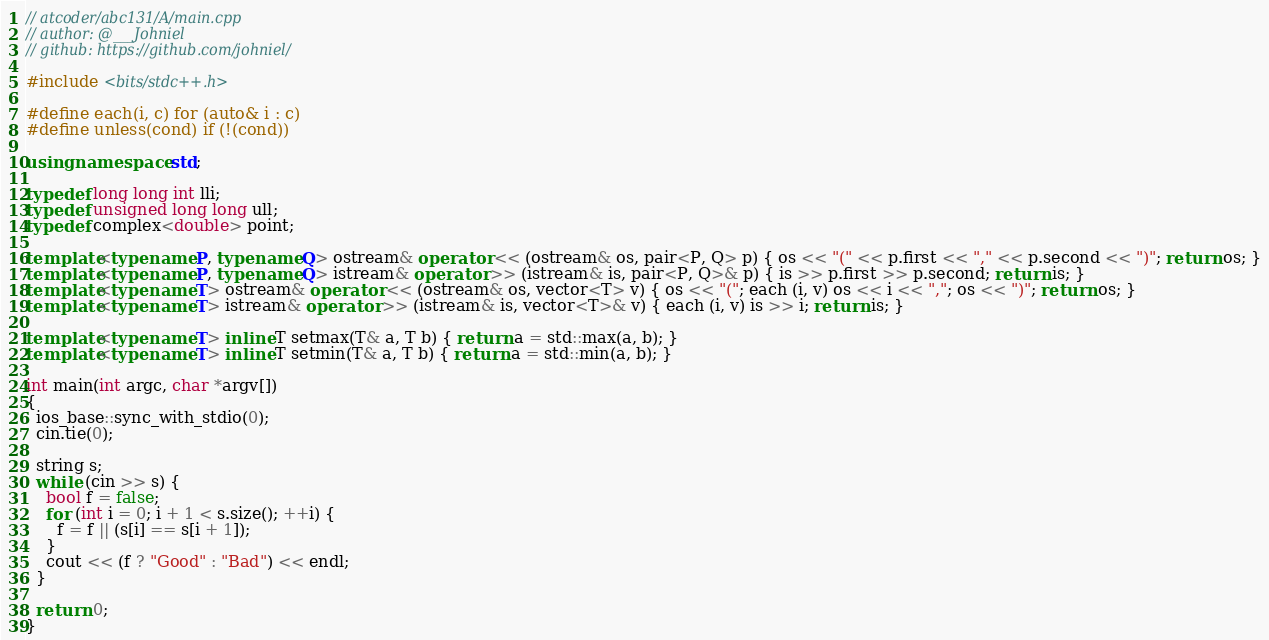<code> <loc_0><loc_0><loc_500><loc_500><_C++_>// atcoder/abc131/A/main.cpp
// author: @___Johniel
// github: https://github.com/johniel/

#include <bits/stdc++.h>

#define each(i, c) for (auto& i : c)
#define unless(cond) if (!(cond))

using namespace std;

typedef long long int lli;
typedef unsigned long long ull;
typedef complex<double> point;

template<typename P, typename Q> ostream& operator << (ostream& os, pair<P, Q> p) { os << "(" << p.first << "," << p.second << ")"; return os; }
template<typename P, typename Q> istream& operator >> (istream& is, pair<P, Q>& p) { is >> p.first >> p.second; return is; }
template<typename T> ostream& operator << (ostream& os, vector<T> v) { os << "("; each (i, v) os << i << ","; os << ")"; return os; }
template<typename T> istream& operator >> (istream& is, vector<T>& v) { each (i, v) is >> i; return is; }

template<typename T> inline T setmax(T& a, T b) { return a = std::max(a, b); }
template<typename T> inline T setmin(T& a, T b) { return a = std::min(a, b); }

int main(int argc, char *argv[])
{
  ios_base::sync_with_stdio(0);
  cin.tie(0);

  string s;
  while (cin >> s) {
    bool f = false;
    for (int i = 0; i + 1 < s.size(); ++i) {
      f = f || (s[i] == s[i + 1]);
    }
    cout << (f ? "Good" : "Bad") << endl;
  }

  return 0;
}
</code> 